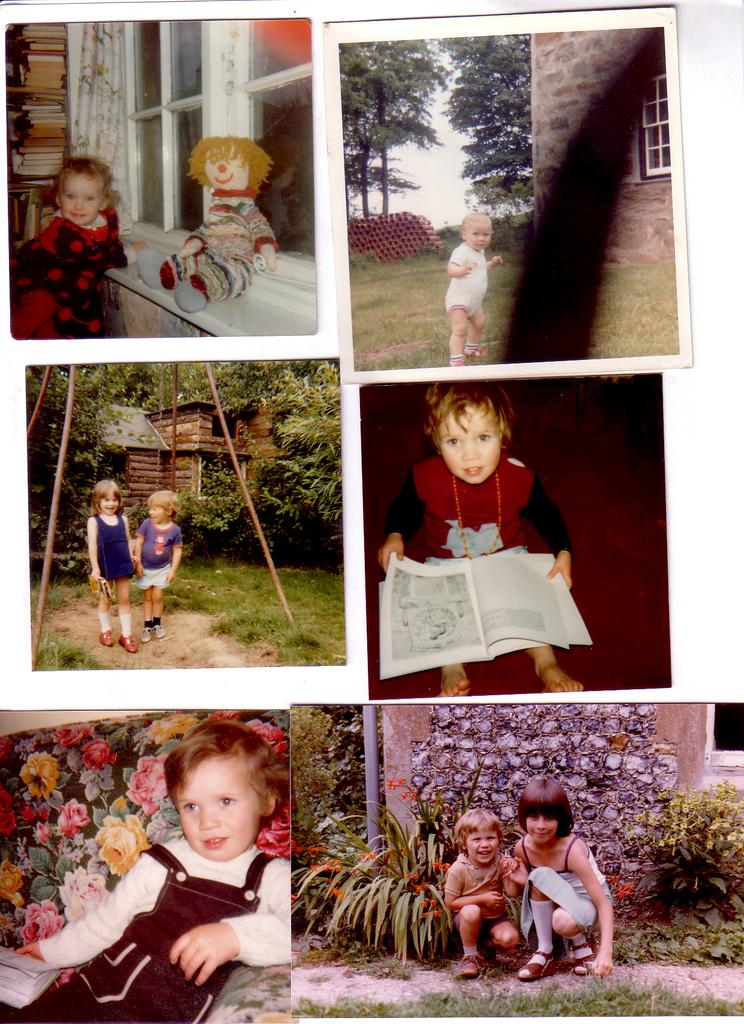How many collage photographs are present in the image? There are six collage photographs in the image. What do the photographs depict? The photographs depict small kids. What are the kids doing in the photographs? The kids are playing and sitting in the image. Where were the photographs taken? The location of the photographs is a park. Can you tell me how many clams are visible in the image? There are no clams present in the image. How does the channel affect the kids playing in the image? There is no mention of a channel in the image, so it cannot be determined how it might affect the kids playing. 